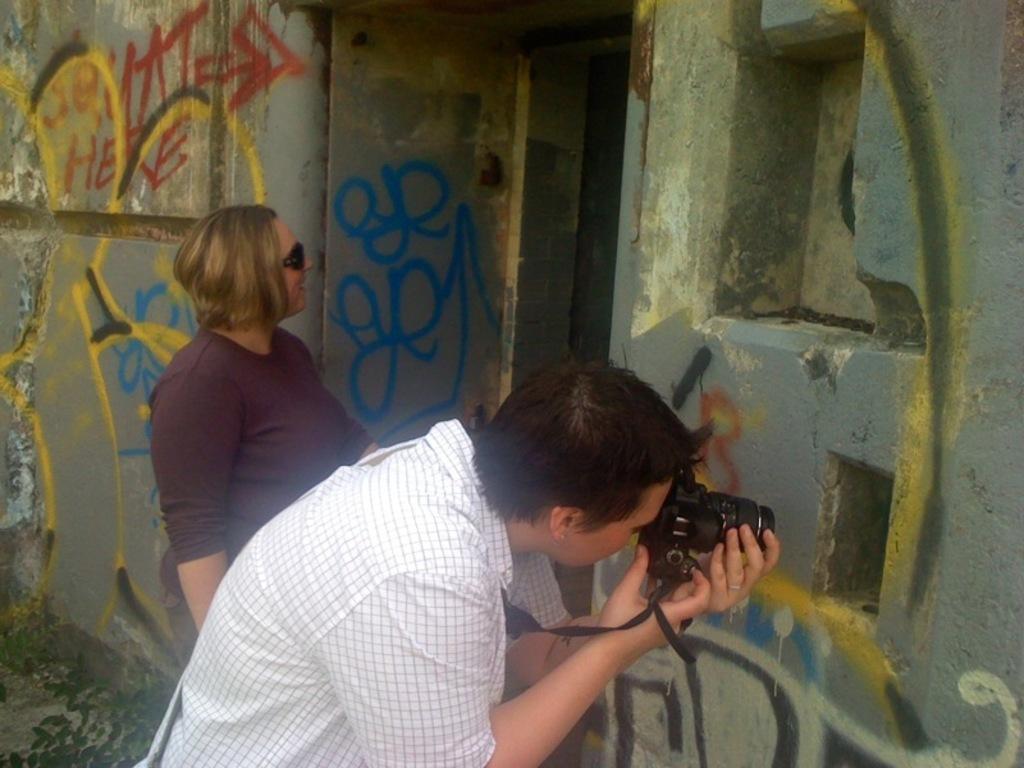Please provide a concise description of this image. In this image in the front there is a person standing and clicking photo with the camera which is black in colour. In the background there is a woman standing and smiling and on the wall there is some text and there are drawings. 